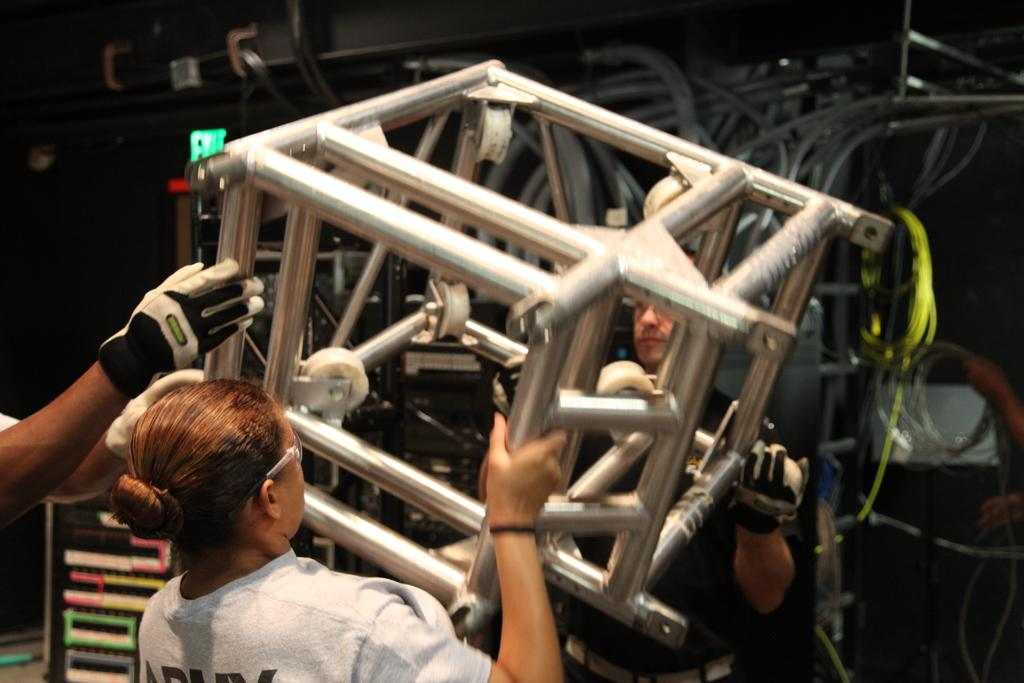Who are the people in the image? There is a man and a woman in the image. What are the man and woman holding? The man and woman are holding a metal frame. Can you describe the person on the left side of the image? There is a person standing on the left side of the image. What can be seen in the background of the image? There are wires and machinery visible in the background of the image. What type of current is flowing through the wires in the image? There is no information about the type of current flowing through the wires in the image. 